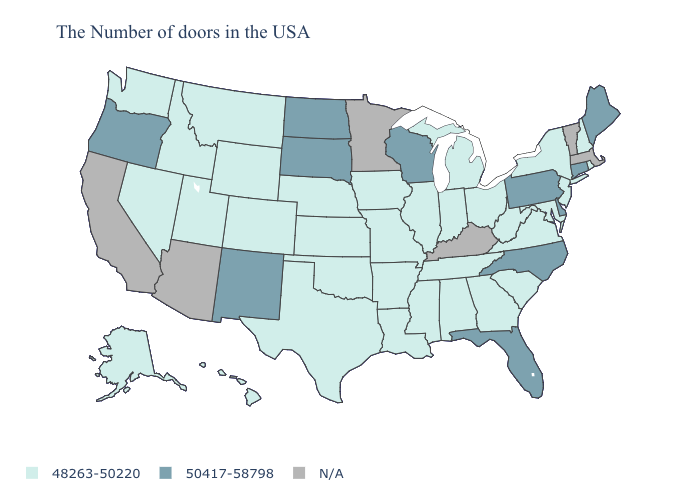Among the states that border Iowa , does South Dakota have the highest value?
Quick response, please. Yes. What is the value of North Dakota?
Give a very brief answer. 50417-58798. Does Montana have the lowest value in the West?
Give a very brief answer. Yes. Does Iowa have the highest value in the MidWest?
Concise answer only. No. Name the states that have a value in the range N/A?
Be succinct. Massachusetts, Vermont, Kentucky, Minnesota, Arizona, California. Does the map have missing data?
Be succinct. Yes. Name the states that have a value in the range N/A?
Keep it brief. Massachusetts, Vermont, Kentucky, Minnesota, Arizona, California. Which states have the lowest value in the USA?
Quick response, please. Rhode Island, New Hampshire, New York, New Jersey, Maryland, Virginia, South Carolina, West Virginia, Ohio, Georgia, Michigan, Indiana, Alabama, Tennessee, Illinois, Mississippi, Louisiana, Missouri, Arkansas, Iowa, Kansas, Nebraska, Oklahoma, Texas, Wyoming, Colorado, Utah, Montana, Idaho, Nevada, Washington, Alaska, Hawaii. What is the value of Nebraska?
Be succinct. 48263-50220. Does North Dakota have the highest value in the MidWest?
Keep it brief. Yes. Does Pennsylvania have the lowest value in the Northeast?
Answer briefly. No. Name the states that have a value in the range 48263-50220?
Answer briefly. Rhode Island, New Hampshire, New York, New Jersey, Maryland, Virginia, South Carolina, West Virginia, Ohio, Georgia, Michigan, Indiana, Alabama, Tennessee, Illinois, Mississippi, Louisiana, Missouri, Arkansas, Iowa, Kansas, Nebraska, Oklahoma, Texas, Wyoming, Colorado, Utah, Montana, Idaho, Nevada, Washington, Alaska, Hawaii. 